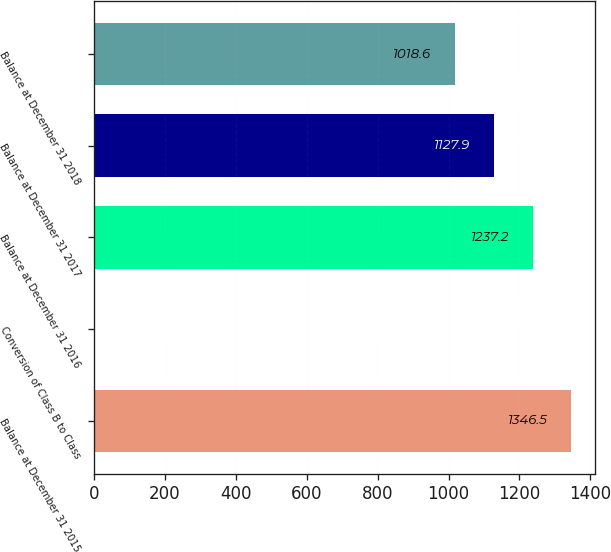Convert chart. <chart><loc_0><loc_0><loc_500><loc_500><bar_chart><fcel>Balance at December 31 2015<fcel>Conversion of Class B to Class<fcel>Balance at December 31 2016<fcel>Balance at December 31 2017<fcel>Balance at December 31 2018<nl><fcel>1346.5<fcel>2<fcel>1237.2<fcel>1127.9<fcel>1018.6<nl></chart> 